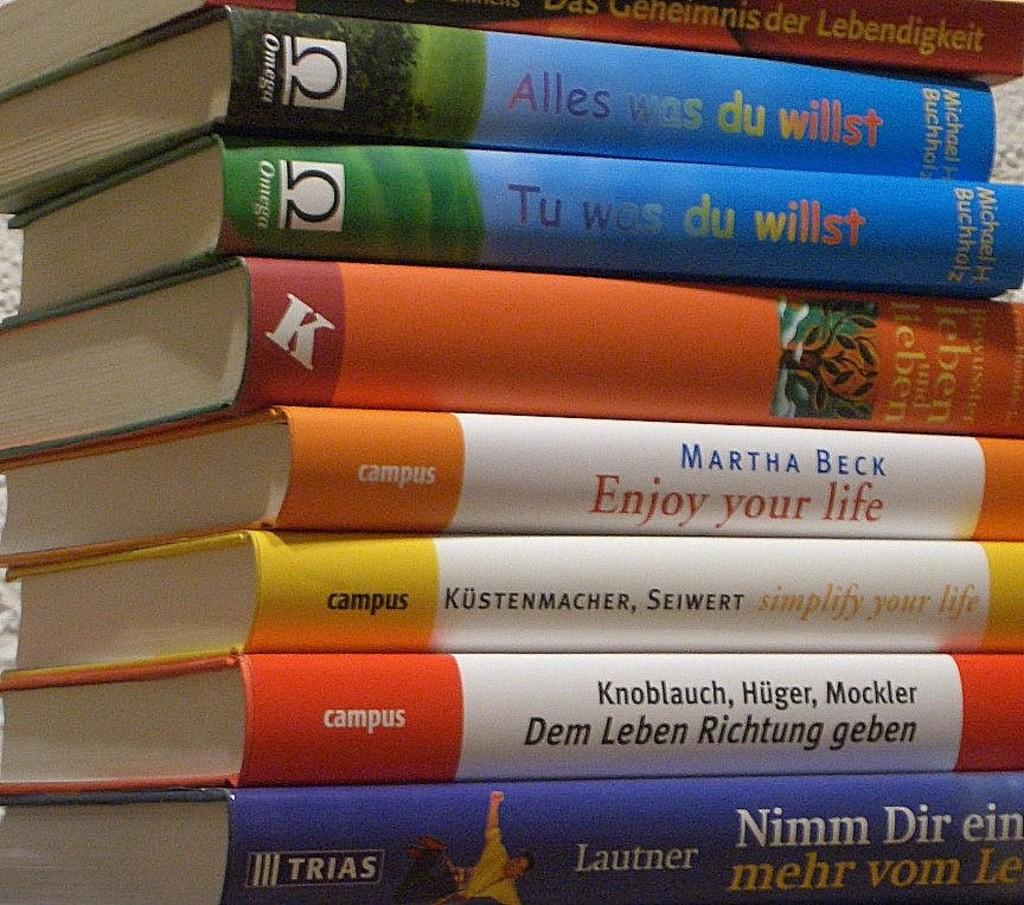<image>
Provide a brief description of the given image. A stack of books includes Enjoy Your Life and Simplify Your Life. 